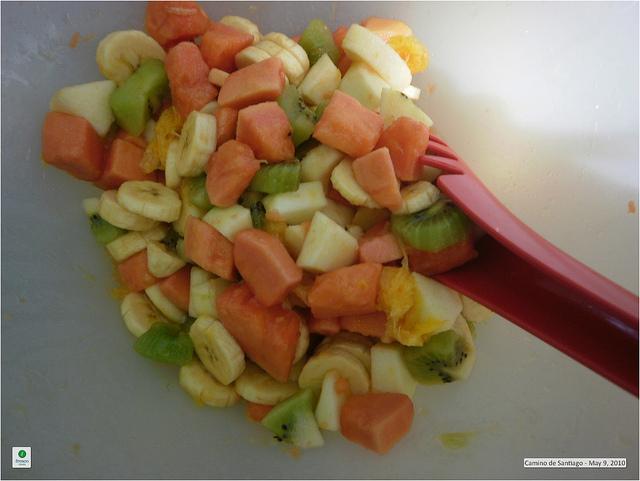How many bananas are in the picture?
Give a very brief answer. 3. How many apples are in the photo?
Give a very brief answer. 3. How many carrots are in the picture?
Give a very brief answer. 8. 